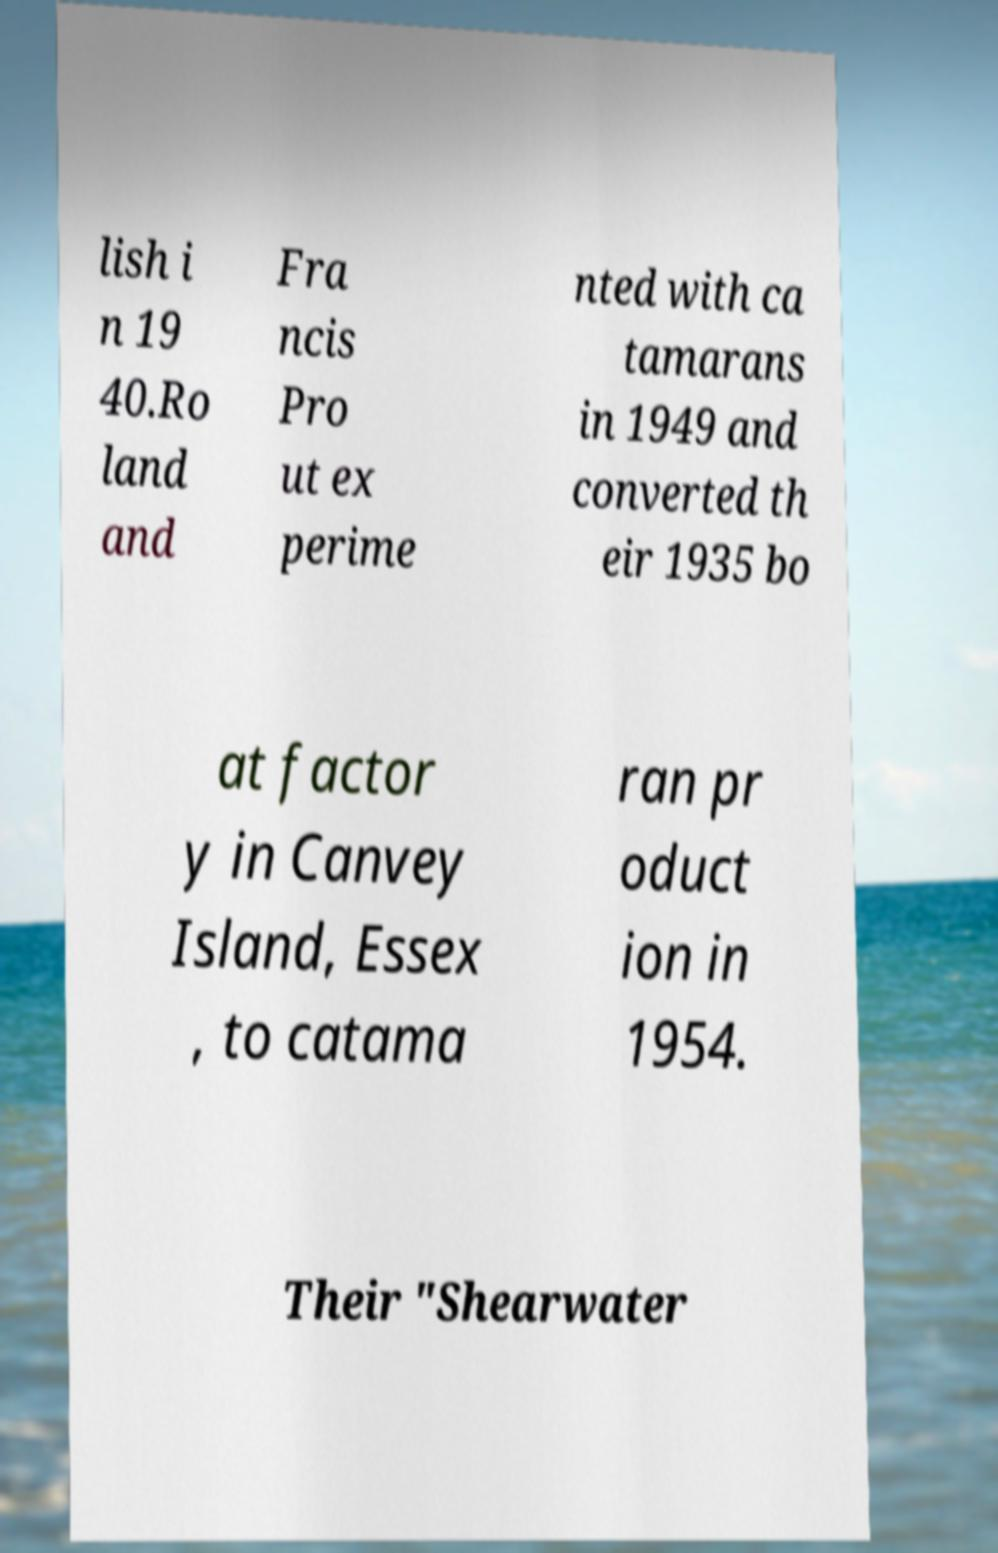Can you read and provide the text displayed in the image?This photo seems to have some interesting text. Can you extract and type it out for me? lish i n 19 40.Ro land and Fra ncis Pro ut ex perime nted with ca tamarans in 1949 and converted th eir 1935 bo at factor y in Canvey Island, Essex , to catama ran pr oduct ion in 1954. Their "Shearwater 